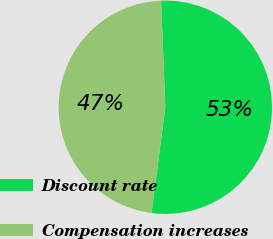<chart> <loc_0><loc_0><loc_500><loc_500><pie_chart><fcel>Discount rate<fcel>Compensation increases<nl><fcel>52.7%<fcel>47.3%<nl></chart> 